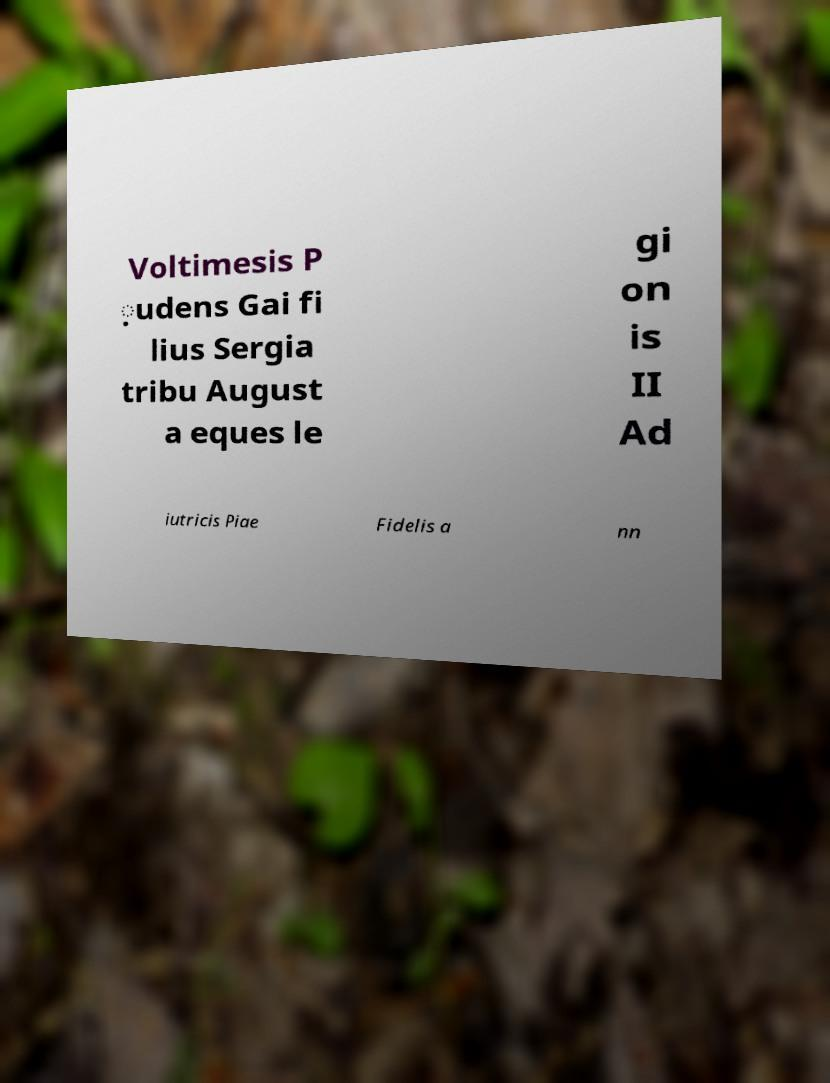Please identify and transcribe the text found in this image. Voltimesis P ̣udens Gai fi lius Sergia tribu August a eques le gi on is II Ad iutricis Piae Fidelis a nn 